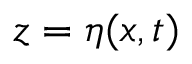Convert formula to latex. <formula><loc_0><loc_0><loc_500><loc_500>z = \eta ( x , t )</formula> 